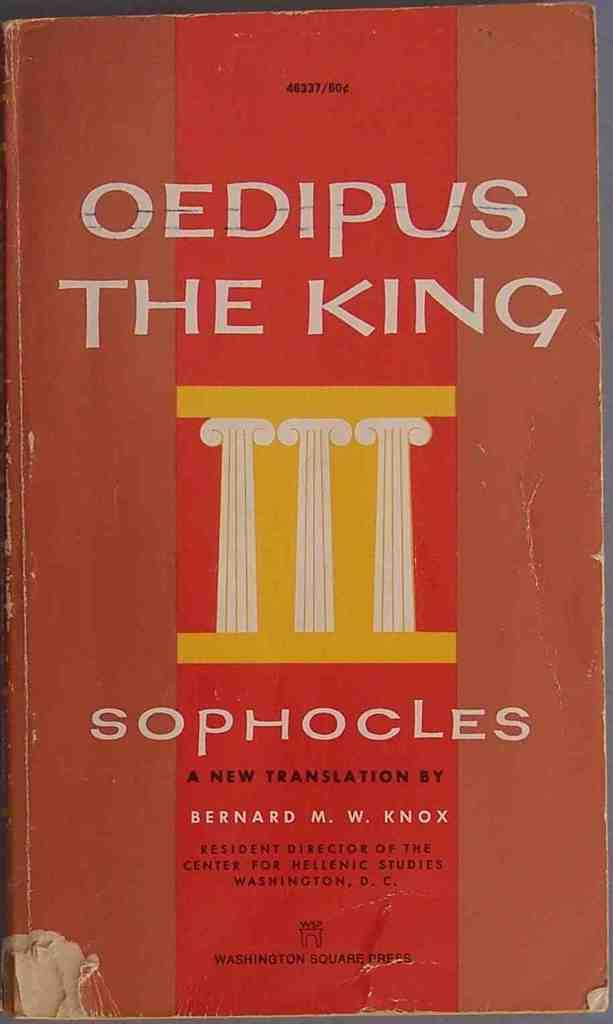<image>
Provide a brief description of the given image. The book Oedipus The King by Sophocles translated by Bernard M. W. Knox. 